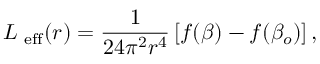<formula> <loc_0><loc_0><loc_500><loc_500>L _ { e f f } ( r ) = \frac { 1 } { 2 4 \pi ^ { 2 } r ^ { 4 } } \left [ f ( \beta ) - f ( \beta _ { o } ) \right ] ,</formula> 